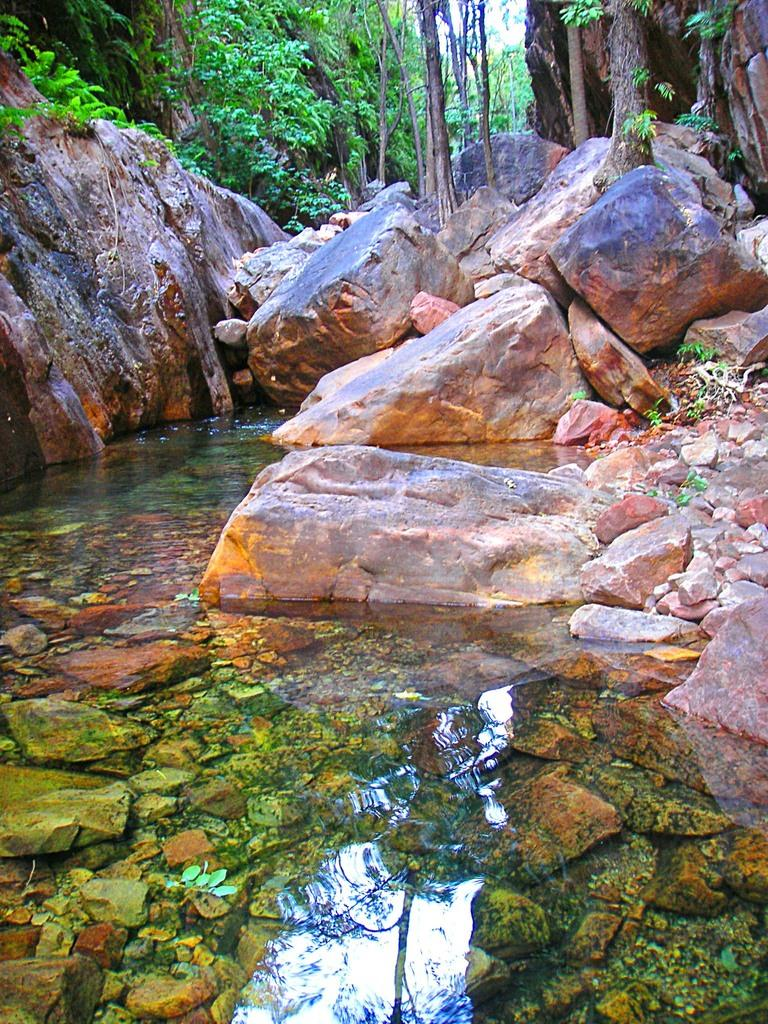What type of natural feature is present in the image? There is a water body in the image. What can be seen in the middle of the water body? There are big rocks in the middle of the image. What type of vegetation is visible at the top of the image? There are trees visible at the top of the image. What type of acoustics can be heard from the cake in the image? There is no cake present in the image, and therefore no acoustics can be heard from it. 